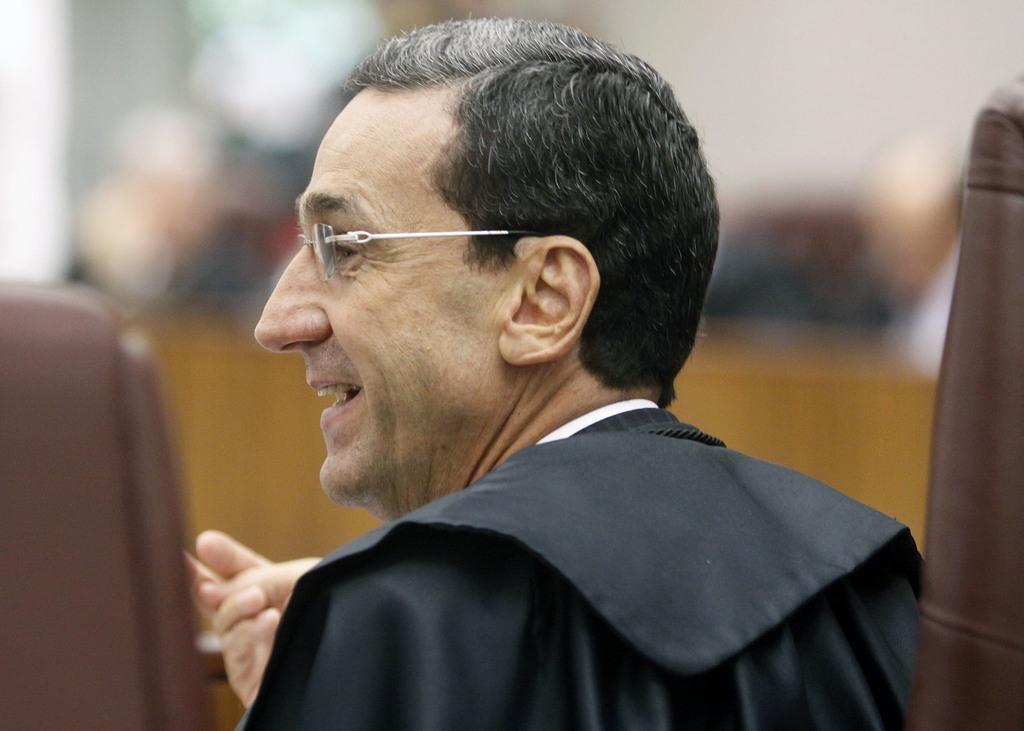Can you describe this image briefly? In the center of the image we can see a person with glasses and the background of the image is blurred. 